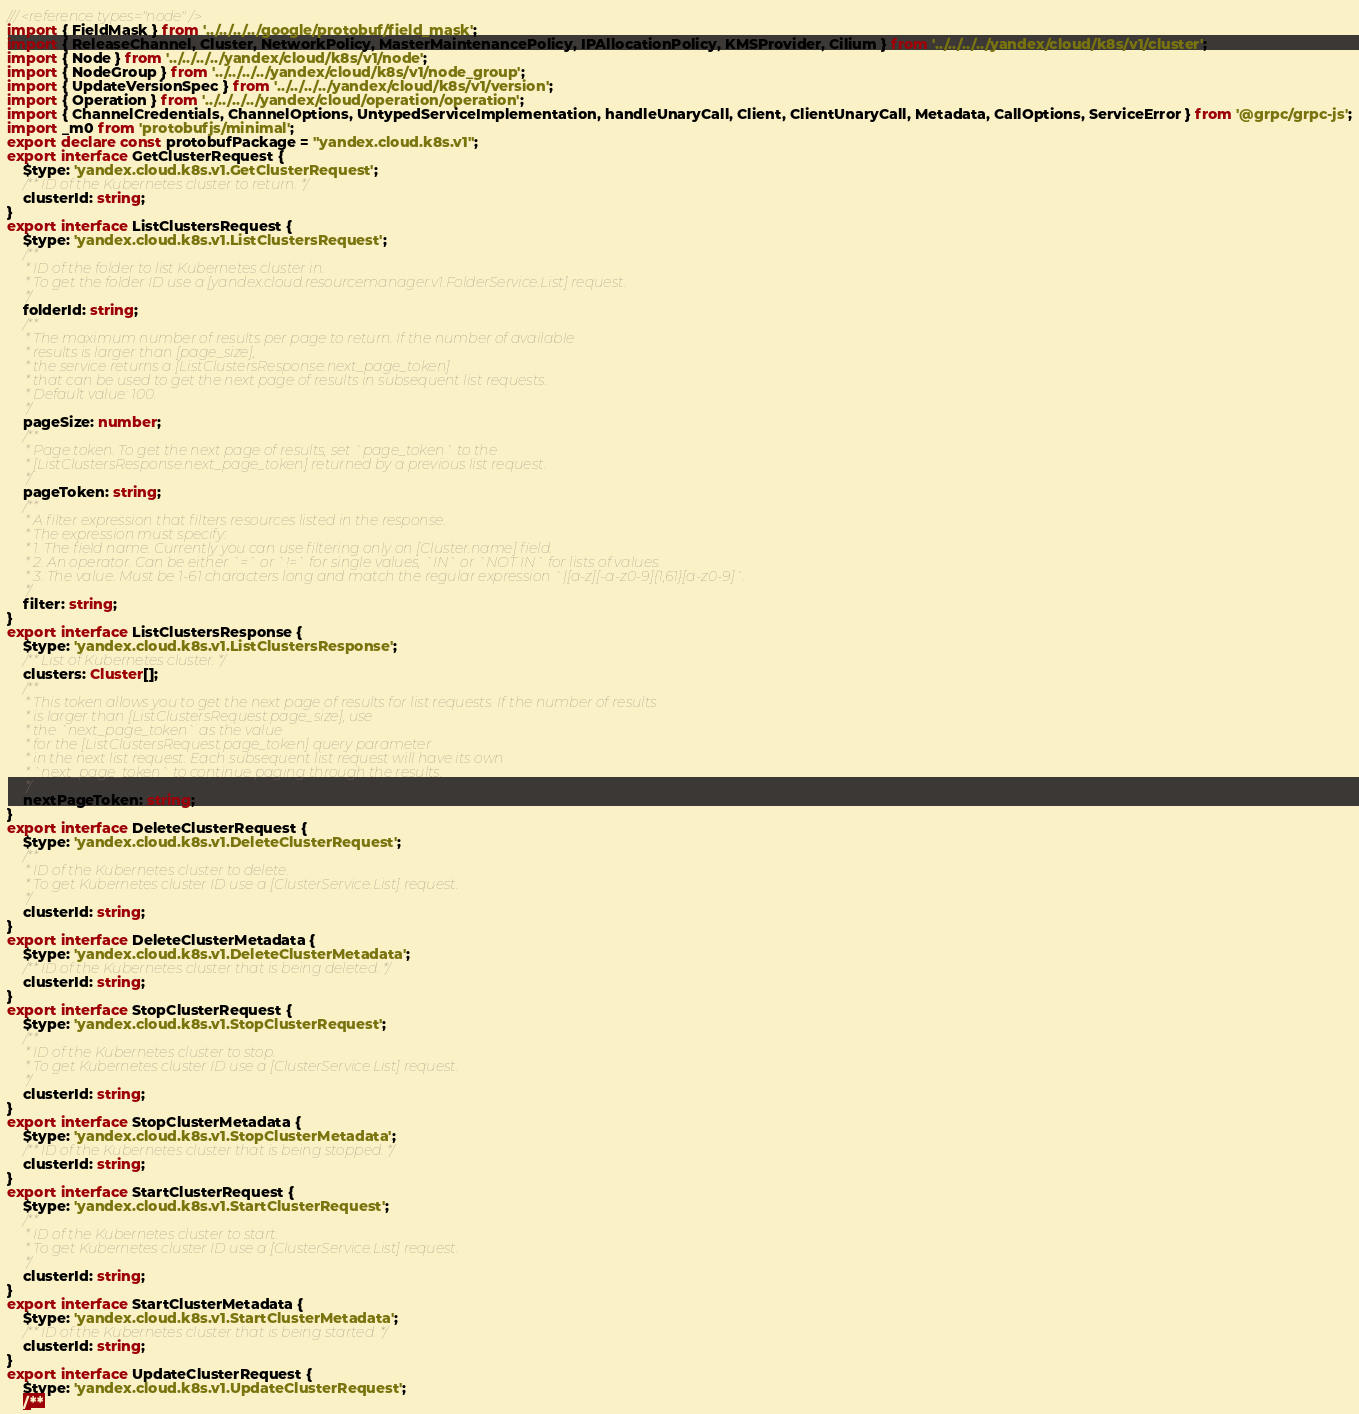Convert code to text. <code><loc_0><loc_0><loc_500><loc_500><_TypeScript_>/// <reference types="node" />
import { FieldMask } from '../../../../google/protobuf/field_mask';
import { ReleaseChannel, Cluster, NetworkPolicy, MasterMaintenancePolicy, IPAllocationPolicy, KMSProvider, Cilium } from '../../../../yandex/cloud/k8s/v1/cluster';
import { Node } from '../../../../yandex/cloud/k8s/v1/node';
import { NodeGroup } from '../../../../yandex/cloud/k8s/v1/node_group';
import { UpdateVersionSpec } from '../../../../yandex/cloud/k8s/v1/version';
import { Operation } from '../../../../yandex/cloud/operation/operation';
import { ChannelCredentials, ChannelOptions, UntypedServiceImplementation, handleUnaryCall, Client, ClientUnaryCall, Metadata, CallOptions, ServiceError } from '@grpc/grpc-js';
import _m0 from 'protobufjs/minimal';
export declare const protobufPackage = "yandex.cloud.k8s.v1";
export interface GetClusterRequest {
    $type: 'yandex.cloud.k8s.v1.GetClusterRequest';
    /** ID of the Kubernetes cluster to return. */
    clusterId: string;
}
export interface ListClustersRequest {
    $type: 'yandex.cloud.k8s.v1.ListClustersRequest';
    /**
     * ID of the folder to list Kubernetes cluster in.
     * To get the folder ID use a [yandex.cloud.resourcemanager.v1.FolderService.List] request.
     */
    folderId: string;
    /**
     * The maximum number of results per page to return. If the number of available
     * results is larger than [page_size],
     * the service returns a [ListClustersResponse.next_page_token]
     * that can be used to get the next page of results in subsequent list requests.
     * Default value: 100.
     */
    pageSize: number;
    /**
     * Page token. To get the next page of results, set `page_token` to the
     * [ListClustersResponse.next_page_token] returned by a previous list request.
     */
    pageToken: string;
    /**
     * A filter expression that filters resources listed in the response.
     * The expression must specify:
     * 1. The field name. Currently you can use filtering only on [Cluster.name] field.
     * 2. An operator. Can be either `=` or `!=` for single values, `IN` or `NOT IN` for lists of values.
     * 3. The value. Must be 1-61 characters long and match the regular expression `|[a-z][-a-z0-9]{1,61}[a-z0-9]`.
     */
    filter: string;
}
export interface ListClustersResponse {
    $type: 'yandex.cloud.k8s.v1.ListClustersResponse';
    /** List of Kubernetes cluster. */
    clusters: Cluster[];
    /**
     * This token allows you to get the next page of results for list requests. If the number of results
     * is larger than [ListClustersRequest.page_size], use
     * the `next_page_token` as the value
     * for the [ListClustersRequest.page_token] query parameter
     * in the next list request. Each subsequent list request will have its own
     * `next_page_token` to continue paging through the results.
     */
    nextPageToken: string;
}
export interface DeleteClusterRequest {
    $type: 'yandex.cloud.k8s.v1.DeleteClusterRequest';
    /**
     * ID of the Kubernetes cluster to delete.
     * To get Kubernetes cluster ID use a [ClusterService.List] request.
     */
    clusterId: string;
}
export interface DeleteClusterMetadata {
    $type: 'yandex.cloud.k8s.v1.DeleteClusterMetadata';
    /** ID of the Kubernetes cluster that is being deleted. */
    clusterId: string;
}
export interface StopClusterRequest {
    $type: 'yandex.cloud.k8s.v1.StopClusterRequest';
    /**
     * ID of the Kubernetes cluster to stop.
     * To get Kubernetes cluster ID use a [ClusterService.List] request.
     */
    clusterId: string;
}
export interface StopClusterMetadata {
    $type: 'yandex.cloud.k8s.v1.StopClusterMetadata';
    /** ID of the Kubernetes cluster that is being stopped. */
    clusterId: string;
}
export interface StartClusterRequest {
    $type: 'yandex.cloud.k8s.v1.StartClusterRequest';
    /**
     * ID of the Kubernetes cluster to start.
     * To get Kubernetes cluster ID use a [ClusterService.List] request.
     */
    clusterId: string;
}
export interface StartClusterMetadata {
    $type: 'yandex.cloud.k8s.v1.StartClusterMetadata';
    /** ID of the Kubernetes cluster that is being started. */
    clusterId: string;
}
export interface UpdateClusterRequest {
    $type: 'yandex.cloud.k8s.v1.UpdateClusterRequest';
    /**</code> 